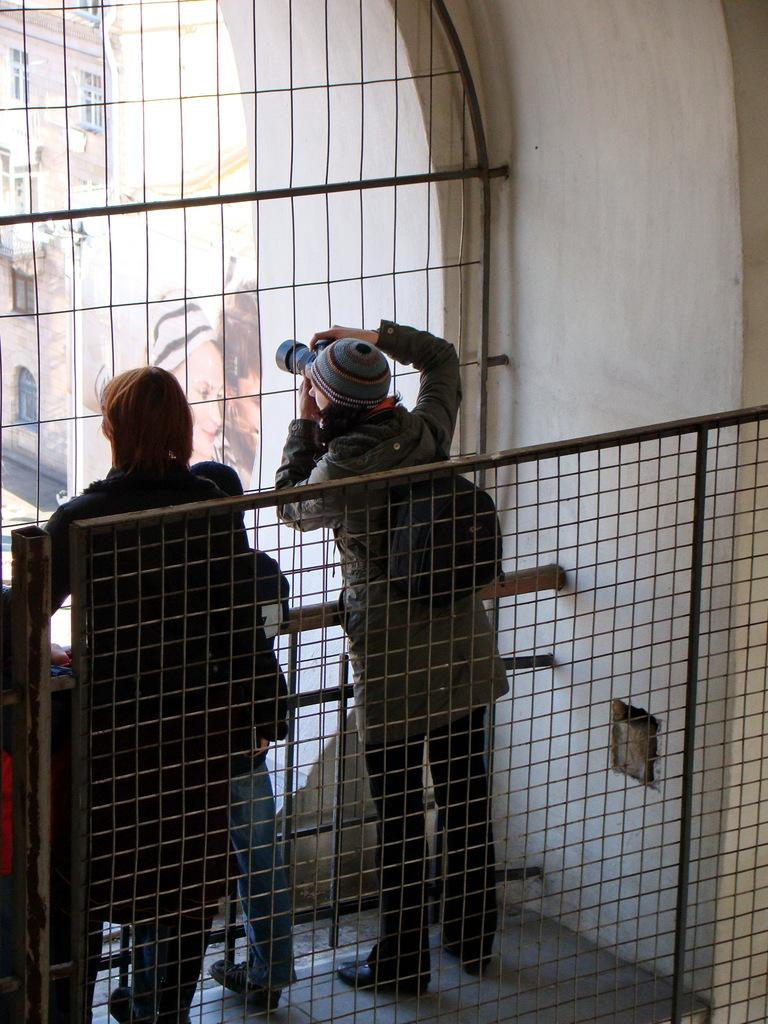How many people are present in the image? There are three members in the image. Can you describe one of the members? One of the members is a kid. What can be seen in the background of the image? There is a fence and a building in the background of the image. What type of crow is perched on the fence in the image? There is no crow present in the image; only the fence and a building can be seen in the background. What type of laborer is working on the building in the image? There is no laborer present in the image; the focus is on the three members and the background elements. 